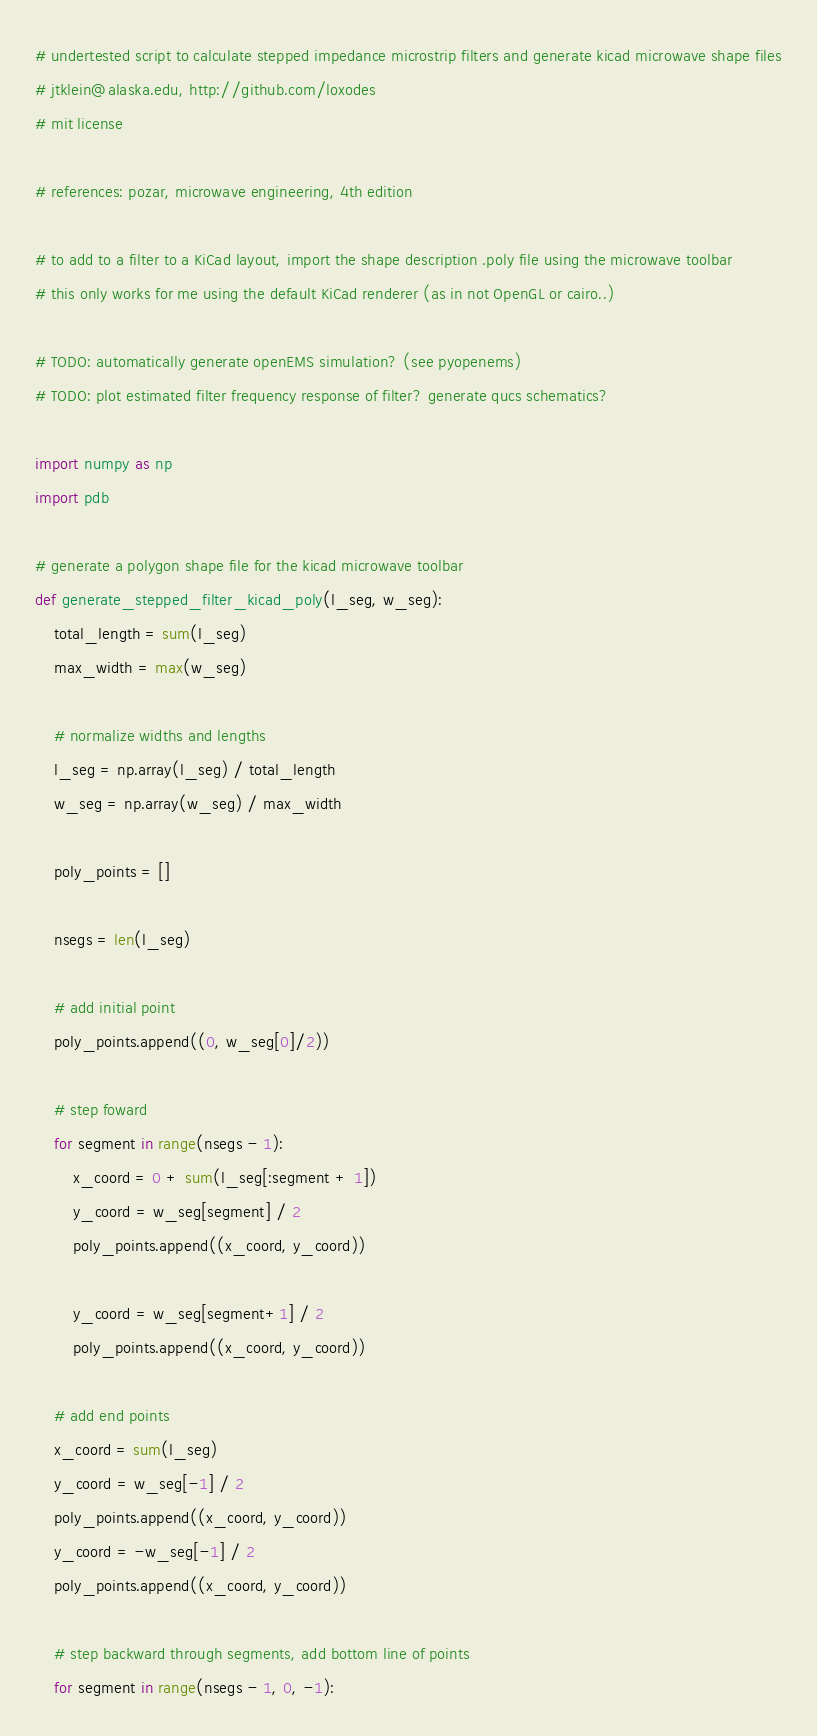<code> <loc_0><loc_0><loc_500><loc_500><_Python_># undertested script to calculate stepped impedance microstrip filters and generate kicad microwave shape files
# jtklein@alaska.edu, http://github.com/loxodes
# mit license

# references: pozar, microwave engineering, 4th edition

# to add to a filter to a KiCad layout, import the shape description .poly file using the microwave toolbar
# this only works for me using the default KiCad renderer (as in not OpenGL or cairo..)

# TODO: automatically generate openEMS simulation? (see pyopenems)
# TODO: plot estimated filter frequency response of filter? generate qucs schematics?

import numpy as np
import pdb

# generate a polygon shape file for the kicad microwave toolbar
def generate_stepped_filter_kicad_poly(l_seg, w_seg):
    total_length = sum(l_seg)
    max_width = max(w_seg)

    # normalize widths and lengths
    l_seg = np.array(l_seg) / total_length
    w_seg = np.array(w_seg) / max_width

    poly_points = []

    nsegs = len(l_seg)
    
    # add initial point
    poly_points.append((0, w_seg[0]/2))
   
    # step foward 
    for segment in range(nsegs - 1):
        x_coord = 0 + sum(l_seg[:segment + 1])
        y_coord = w_seg[segment] / 2
        poly_points.append((x_coord, y_coord))

        y_coord = w_seg[segment+1] / 2
        poly_points.append((x_coord, y_coord))

    # add end points
    x_coord = sum(l_seg)
    y_coord = w_seg[-1] / 2
    poly_points.append((x_coord, y_coord))
    y_coord = -w_seg[-1] / 2
    poly_points.append((x_coord, y_coord))

    # step backward through segments, add bottom line of points
    for segment in range(nsegs - 1, 0, -1):</code> 